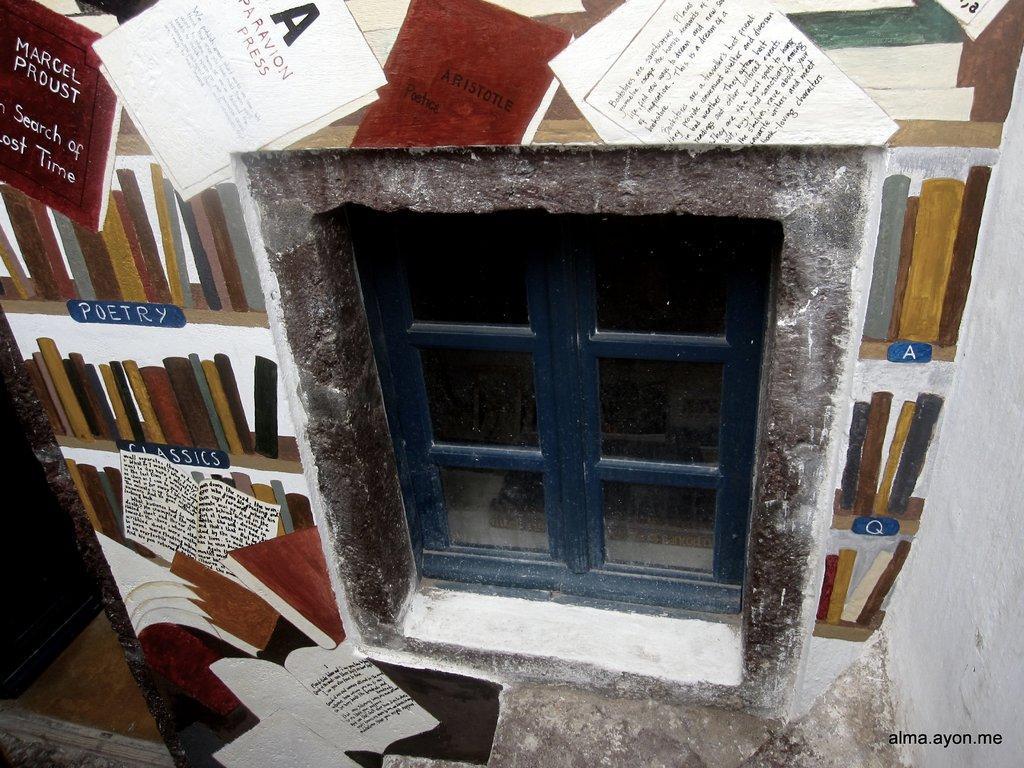Describe this image in one or two sentences. In the center of the image there is a window with glass doors. On the left side of the image there is a door. There is a painting on the wall. There is some text on the right side of the image. 